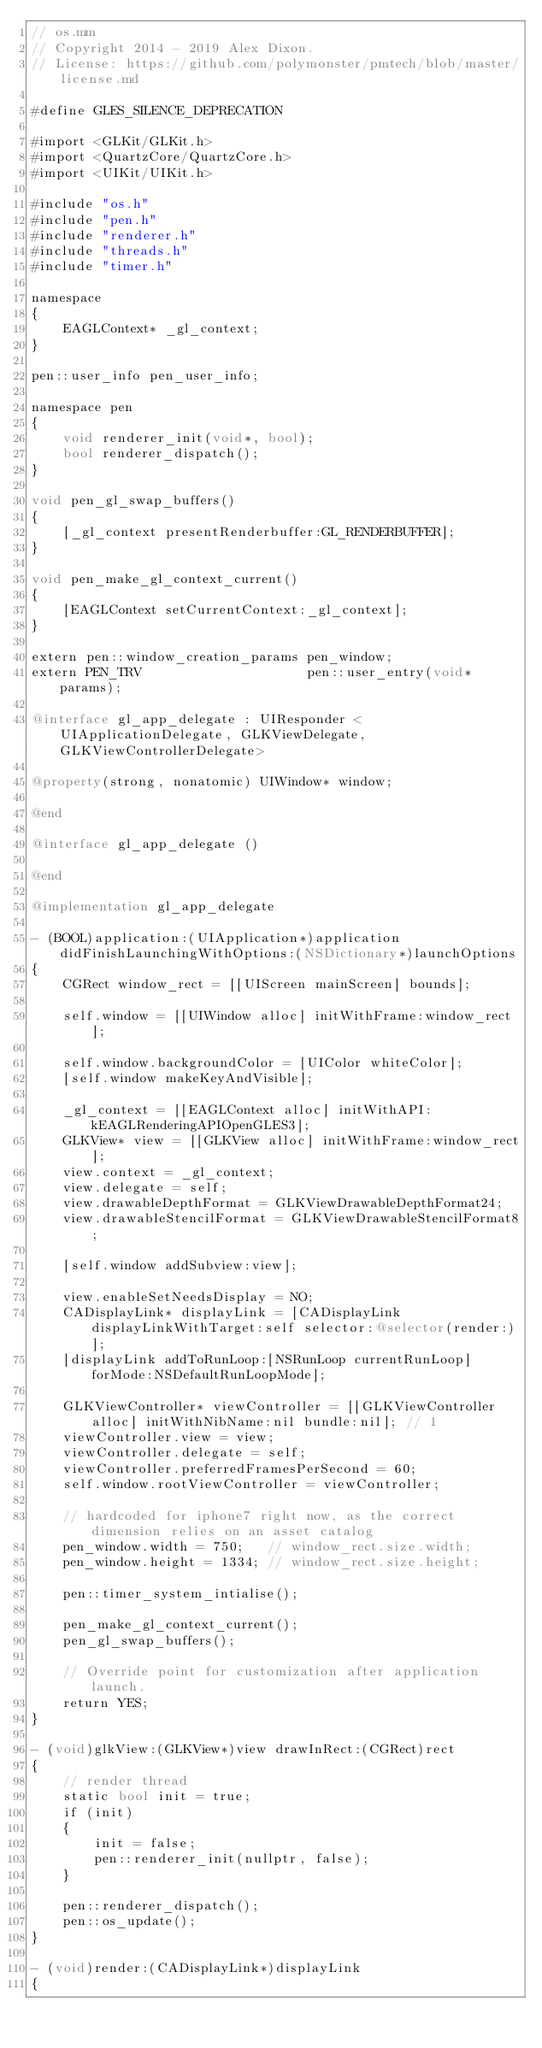Convert code to text. <code><loc_0><loc_0><loc_500><loc_500><_ObjectiveC_>// os.mm
// Copyright 2014 - 2019 Alex Dixon.
// License: https://github.com/polymonster/pmtech/blob/master/license.md

#define GLES_SILENCE_DEPRECATION

#import <GLKit/GLKit.h>
#import <QuartzCore/QuartzCore.h>
#import <UIKit/UIKit.h>

#include "os.h"
#include "pen.h"
#include "renderer.h"
#include "threads.h"
#include "timer.h"

namespace
{
    EAGLContext* _gl_context;
}

pen::user_info pen_user_info;

namespace pen
{
    void renderer_init(void*, bool);
    bool renderer_dispatch();
}

void pen_gl_swap_buffers()
{
    [_gl_context presentRenderbuffer:GL_RENDERBUFFER];
}

void pen_make_gl_context_current()
{
    [EAGLContext setCurrentContext:_gl_context];
}

extern pen::window_creation_params pen_window;
extern PEN_TRV                     pen::user_entry(void* params);

@interface gl_app_delegate : UIResponder <UIApplicationDelegate, GLKViewDelegate, GLKViewControllerDelegate>

@property(strong, nonatomic) UIWindow* window;

@end

@interface gl_app_delegate ()

@end

@implementation gl_app_delegate

- (BOOL)application:(UIApplication*)application didFinishLaunchingWithOptions:(NSDictionary*)launchOptions
{
    CGRect window_rect = [[UIScreen mainScreen] bounds];

    self.window = [[UIWindow alloc] initWithFrame:window_rect];

    self.window.backgroundColor = [UIColor whiteColor];
    [self.window makeKeyAndVisible];

    _gl_context = [[EAGLContext alloc] initWithAPI:kEAGLRenderingAPIOpenGLES3];
    GLKView* view = [[GLKView alloc] initWithFrame:window_rect];
    view.context = _gl_context;
    view.delegate = self;
    view.drawableDepthFormat = GLKViewDrawableDepthFormat24;
    view.drawableStencilFormat = GLKViewDrawableStencilFormat8;

    [self.window addSubview:view];

    view.enableSetNeedsDisplay = NO;
    CADisplayLink* displayLink = [CADisplayLink displayLinkWithTarget:self selector:@selector(render:)];
    [displayLink addToRunLoop:[NSRunLoop currentRunLoop] forMode:NSDefaultRunLoopMode];

    GLKViewController* viewController = [[GLKViewController alloc] initWithNibName:nil bundle:nil]; // 1
    viewController.view = view;
    viewController.delegate = self;
    viewController.preferredFramesPerSecond = 60;
    self.window.rootViewController = viewController;

    // hardcoded for iphone7 right now, as the correct dimension relies on an asset catalog
    pen_window.width = 750;   // window_rect.size.width;
    pen_window.height = 1334; // window_rect.size.height;

    pen::timer_system_intialise();

    pen_make_gl_context_current();
    pen_gl_swap_buffers();

    // Override point for customization after application launch.
    return YES;
}

- (void)glkView:(GLKView*)view drawInRect:(CGRect)rect
{
    // render thread
    static bool init = true;
    if (init)
    {
        init = false;
        pen::renderer_init(nullptr, false);
    }

    pen::renderer_dispatch();
    pen::os_update();
}

- (void)render:(CADisplayLink*)displayLink
{</code> 